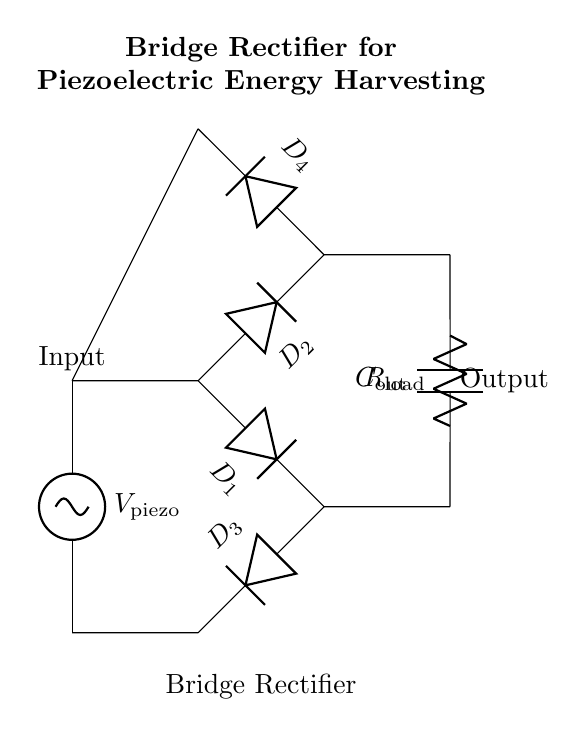What is the input voltage source in this circuit? The input voltage source is labeled as V_piezo, indicating the voltage supplied by the piezoelectric materials.
Answer: V_piezo How many diodes are used in the bridge rectifier? There are four diodes in the bridge rectifier, labeled D1, D2, D3, and D4, connected in a specific configuration for rectification.
Answer: Four What is the role of the capacitor in this circuit? The capacitor, labeled C_out, is used to smooth the output voltage by filtering out fluctuations and providing a stable output.
Answer: Smoothing What connections are made from the output of the diodes? The output of the diodes connects to a load resistor R_load and the output capacitor C_out, establishing the circuit's output path.
Answer: R_load and C_out Which component indicates the load in the circuit? The load is represented by a resistor labeled R_load, which is connected to the output side of the bridge rectifier and capacitor.
Answer: R_load What is the primary purpose of this configuration? The primary purpose of this configuration is to convert alternating voltage from piezoelectric materials into a usable direct voltage output.
Answer: Energy harvesting 